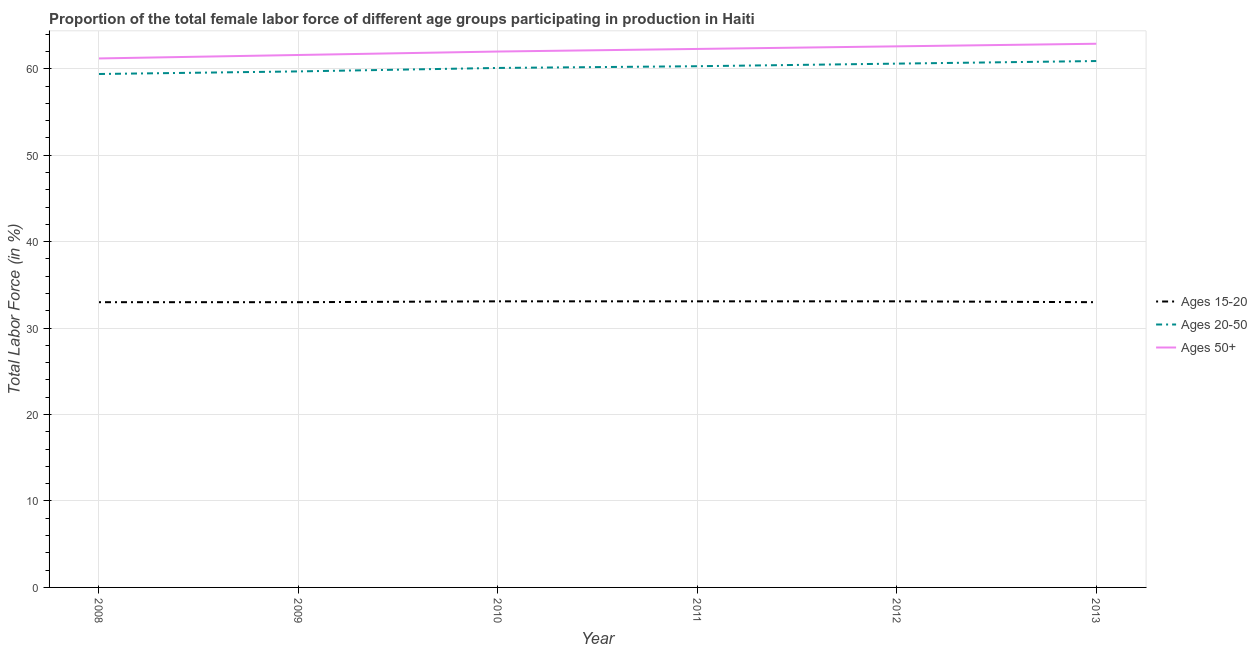How many different coloured lines are there?
Your answer should be very brief. 3. What is the percentage of female labor force above age 50 in 2011?
Offer a very short reply. 62.3. Across all years, what is the maximum percentage of female labor force above age 50?
Your answer should be very brief. 62.9. Across all years, what is the minimum percentage of female labor force within the age group 20-50?
Offer a terse response. 59.4. What is the total percentage of female labor force within the age group 15-20 in the graph?
Your answer should be very brief. 198.3. What is the difference between the percentage of female labor force within the age group 20-50 in 2009 and that in 2011?
Your response must be concise. -0.6. What is the difference between the percentage of female labor force within the age group 20-50 in 2013 and the percentage of female labor force above age 50 in 2008?
Ensure brevity in your answer.  -0.3. What is the average percentage of female labor force within the age group 20-50 per year?
Provide a short and direct response. 60.17. In the year 2009, what is the difference between the percentage of female labor force within the age group 15-20 and percentage of female labor force within the age group 20-50?
Your response must be concise. -26.7. In how many years, is the percentage of female labor force above age 50 greater than 54 %?
Provide a short and direct response. 6. What is the ratio of the percentage of female labor force within the age group 20-50 in 2009 to that in 2012?
Your answer should be compact. 0.99. Is the percentage of female labor force above age 50 in 2011 less than that in 2013?
Provide a succinct answer. Yes. What is the difference between the highest and the second highest percentage of female labor force within the age group 20-50?
Keep it short and to the point. 0.3. What is the difference between the highest and the lowest percentage of female labor force above age 50?
Give a very brief answer. 1.7. Does the percentage of female labor force within the age group 15-20 monotonically increase over the years?
Make the answer very short. No. Is the percentage of female labor force above age 50 strictly greater than the percentage of female labor force within the age group 20-50 over the years?
Your answer should be very brief. Yes. How many years are there in the graph?
Offer a very short reply. 6. How many legend labels are there?
Ensure brevity in your answer.  3. What is the title of the graph?
Offer a very short reply. Proportion of the total female labor force of different age groups participating in production in Haiti. Does "Unpaid family workers" appear as one of the legend labels in the graph?
Your answer should be compact. No. What is the label or title of the Y-axis?
Your answer should be compact. Total Labor Force (in %). What is the Total Labor Force (in %) of Ages 15-20 in 2008?
Your response must be concise. 33. What is the Total Labor Force (in %) of Ages 20-50 in 2008?
Give a very brief answer. 59.4. What is the Total Labor Force (in %) of Ages 50+ in 2008?
Make the answer very short. 61.2. What is the Total Labor Force (in %) in Ages 15-20 in 2009?
Your answer should be compact. 33. What is the Total Labor Force (in %) in Ages 20-50 in 2009?
Ensure brevity in your answer.  59.7. What is the Total Labor Force (in %) in Ages 50+ in 2009?
Your answer should be very brief. 61.6. What is the Total Labor Force (in %) of Ages 15-20 in 2010?
Offer a terse response. 33.1. What is the Total Labor Force (in %) in Ages 20-50 in 2010?
Provide a succinct answer. 60.1. What is the Total Labor Force (in %) in Ages 15-20 in 2011?
Ensure brevity in your answer.  33.1. What is the Total Labor Force (in %) in Ages 20-50 in 2011?
Offer a terse response. 60.3. What is the Total Labor Force (in %) in Ages 50+ in 2011?
Your answer should be very brief. 62.3. What is the Total Labor Force (in %) of Ages 15-20 in 2012?
Give a very brief answer. 33.1. What is the Total Labor Force (in %) of Ages 20-50 in 2012?
Offer a very short reply. 60.6. What is the Total Labor Force (in %) in Ages 50+ in 2012?
Make the answer very short. 62.6. What is the Total Labor Force (in %) in Ages 20-50 in 2013?
Keep it short and to the point. 60.9. What is the Total Labor Force (in %) in Ages 50+ in 2013?
Offer a terse response. 62.9. Across all years, what is the maximum Total Labor Force (in %) of Ages 15-20?
Your response must be concise. 33.1. Across all years, what is the maximum Total Labor Force (in %) of Ages 20-50?
Keep it short and to the point. 60.9. Across all years, what is the maximum Total Labor Force (in %) in Ages 50+?
Offer a terse response. 62.9. Across all years, what is the minimum Total Labor Force (in %) of Ages 15-20?
Ensure brevity in your answer.  33. Across all years, what is the minimum Total Labor Force (in %) in Ages 20-50?
Offer a very short reply. 59.4. Across all years, what is the minimum Total Labor Force (in %) in Ages 50+?
Give a very brief answer. 61.2. What is the total Total Labor Force (in %) of Ages 15-20 in the graph?
Provide a succinct answer. 198.3. What is the total Total Labor Force (in %) of Ages 20-50 in the graph?
Provide a short and direct response. 361. What is the total Total Labor Force (in %) in Ages 50+ in the graph?
Offer a very short reply. 372.6. What is the difference between the Total Labor Force (in %) in Ages 15-20 in 2008 and that in 2009?
Your answer should be compact. 0. What is the difference between the Total Labor Force (in %) of Ages 20-50 in 2008 and that in 2010?
Keep it short and to the point. -0.7. What is the difference between the Total Labor Force (in %) of Ages 15-20 in 2008 and that in 2011?
Keep it short and to the point. -0.1. What is the difference between the Total Labor Force (in %) in Ages 20-50 in 2008 and that in 2011?
Offer a terse response. -0.9. What is the difference between the Total Labor Force (in %) in Ages 15-20 in 2008 and that in 2012?
Provide a succinct answer. -0.1. What is the difference between the Total Labor Force (in %) of Ages 15-20 in 2008 and that in 2013?
Offer a terse response. 0. What is the difference between the Total Labor Force (in %) of Ages 20-50 in 2008 and that in 2013?
Keep it short and to the point. -1.5. What is the difference between the Total Labor Force (in %) of Ages 50+ in 2009 and that in 2010?
Give a very brief answer. -0.4. What is the difference between the Total Labor Force (in %) of Ages 15-20 in 2009 and that in 2011?
Give a very brief answer. -0.1. What is the difference between the Total Labor Force (in %) in Ages 50+ in 2009 and that in 2011?
Keep it short and to the point. -0.7. What is the difference between the Total Labor Force (in %) in Ages 20-50 in 2009 and that in 2012?
Give a very brief answer. -0.9. What is the difference between the Total Labor Force (in %) of Ages 20-50 in 2009 and that in 2013?
Provide a succinct answer. -1.2. What is the difference between the Total Labor Force (in %) of Ages 20-50 in 2010 and that in 2011?
Your response must be concise. -0.2. What is the difference between the Total Labor Force (in %) in Ages 50+ in 2010 and that in 2011?
Your answer should be compact. -0.3. What is the difference between the Total Labor Force (in %) of Ages 15-20 in 2010 and that in 2012?
Your answer should be very brief. 0. What is the difference between the Total Labor Force (in %) in Ages 15-20 in 2010 and that in 2013?
Provide a short and direct response. 0.1. What is the difference between the Total Labor Force (in %) in Ages 20-50 in 2010 and that in 2013?
Your answer should be very brief. -0.8. What is the difference between the Total Labor Force (in %) of Ages 50+ in 2011 and that in 2012?
Give a very brief answer. -0.3. What is the difference between the Total Labor Force (in %) of Ages 15-20 in 2011 and that in 2013?
Provide a short and direct response. 0.1. What is the difference between the Total Labor Force (in %) of Ages 15-20 in 2012 and that in 2013?
Give a very brief answer. 0.1. What is the difference between the Total Labor Force (in %) in Ages 20-50 in 2012 and that in 2013?
Provide a short and direct response. -0.3. What is the difference between the Total Labor Force (in %) in Ages 15-20 in 2008 and the Total Labor Force (in %) in Ages 20-50 in 2009?
Provide a short and direct response. -26.7. What is the difference between the Total Labor Force (in %) of Ages 15-20 in 2008 and the Total Labor Force (in %) of Ages 50+ in 2009?
Offer a terse response. -28.6. What is the difference between the Total Labor Force (in %) of Ages 20-50 in 2008 and the Total Labor Force (in %) of Ages 50+ in 2009?
Ensure brevity in your answer.  -2.2. What is the difference between the Total Labor Force (in %) in Ages 15-20 in 2008 and the Total Labor Force (in %) in Ages 20-50 in 2010?
Keep it short and to the point. -27.1. What is the difference between the Total Labor Force (in %) of Ages 20-50 in 2008 and the Total Labor Force (in %) of Ages 50+ in 2010?
Give a very brief answer. -2.6. What is the difference between the Total Labor Force (in %) in Ages 15-20 in 2008 and the Total Labor Force (in %) in Ages 20-50 in 2011?
Provide a succinct answer. -27.3. What is the difference between the Total Labor Force (in %) of Ages 15-20 in 2008 and the Total Labor Force (in %) of Ages 50+ in 2011?
Provide a short and direct response. -29.3. What is the difference between the Total Labor Force (in %) of Ages 20-50 in 2008 and the Total Labor Force (in %) of Ages 50+ in 2011?
Give a very brief answer. -2.9. What is the difference between the Total Labor Force (in %) in Ages 15-20 in 2008 and the Total Labor Force (in %) in Ages 20-50 in 2012?
Your response must be concise. -27.6. What is the difference between the Total Labor Force (in %) in Ages 15-20 in 2008 and the Total Labor Force (in %) in Ages 50+ in 2012?
Your answer should be compact. -29.6. What is the difference between the Total Labor Force (in %) in Ages 20-50 in 2008 and the Total Labor Force (in %) in Ages 50+ in 2012?
Keep it short and to the point. -3.2. What is the difference between the Total Labor Force (in %) in Ages 15-20 in 2008 and the Total Labor Force (in %) in Ages 20-50 in 2013?
Keep it short and to the point. -27.9. What is the difference between the Total Labor Force (in %) in Ages 15-20 in 2008 and the Total Labor Force (in %) in Ages 50+ in 2013?
Your answer should be very brief. -29.9. What is the difference between the Total Labor Force (in %) in Ages 20-50 in 2008 and the Total Labor Force (in %) in Ages 50+ in 2013?
Offer a terse response. -3.5. What is the difference between the Total Labor Force (in %) of Ages 15-20 in 2009 and the Total Labor Force (in %) of Ages 20-50 in 2010?
Give a very brief answer. -27.1. What is the difference between the Total Labor Force (in %) in Ages 20-50 in 2009 and the Total Labor Force (in %) in Ages 50+ in 2010?
Your answer should be compact. -2.3. What is the difference between the Total Labor Force (in %) in Ages 15-20 in 2009 and the Total Labor Force (in %) in Ages 20-50 in 2011?
Your response must be concise. -27.3. What is the difference between the Total Labor Force (in %) of Ages 15-20 in 2009 and the Total Labor Force (in %) of Ages 50+ in 2011?
Your answer should be compact. -29.3. What is the difference between the Total Labor Force (in %) of Ages 20-50 in 2009 and the Total Labor Force (in %) of Ages 50+ in 2011?
Offer a very short reply. -2.6. What is the difference between the Total Labor Force (in %) of Ages 15-20 in 2009 and the Total Labor Force (in %) of Ages 20-50 in 2012?
Provide a succinct answer. -27.6. What is the difference between the Total Labor Force (in %) in Ages 15-20 in 2009 and the Total Labor Force (in %) in Ages 50+ in 2012?
Make the answer very short. -29.6. What is the difference between the Total Labor Force (in %) of Ages 15-20 in 2009 and the Total Labor Force (in %) of Ages 20-50 in 2013?
Ensure brevity in your answer.  -27.9. What is the difference between the Total Labor Force (in %) of Ages 15-20 in 2009 and the Total Labor Force (in %) of Ages 50+ in 2013?
Give a very brief answer. -29.9. What is the difference between the Total Labor Force (in %) of Ages 15-20 in 2010 and the Total Labor Force (in %) of Ages 20-50 in 2011?
Provide a short and direct response. -27.2. What is the difference between the Total Labor Force (in %) of Ages 15-20 in 2010 and the Total Labor Force (in %) of Ages 50+ in 2011?
Your response must be concise. -29.2. What is the difference between the Total Labor Force (in %) of Ages 20-50 in 2010 and the Total Labor Force (in %) of Ages 50+ in 2011?
Offer a very short reply. -2.2. What is the difference between the Total Labor Force (in %) of Ages 15-20 in 2010 and the Total Labor Force (in %) of Ages 20-50 in 2012?
Offer a terse response. -27.5. What is the difference between the Total Labor Force (in %) of Ages 15-20 in 2010 and the Total Labor Force (in %) of Ages 50+ in 2012?
Give a very brief answer. -29.5. What is the difference between the Total Labor Force (in %) of Ages 15-20 in 2010 and the Total Labor Force (in %) of Ages 20-50 in 2013?
Your response must be concise. -27.8. What is the difference between the Total Labor Force (in %) in Ages 15-20 in 2010 and the Total Labor Force (in %) in Ages 50+ in 2013?
Keep it short and to the point. -29.8. What is the difference between the Total Labor Force (in %) of Ages 20-50 in 2010 and the Total Labor Force (in %) of Ages 50+ in 2013?
Your answer should be compact. -2.8. What is the difference between the Total Labor Force (in %) in Ages 15-20 in 2011 and the Total Labor Force (in %) in Ages 20-50 in 2012?
Provide a short and direct response. -27.5. What is the difference between the Total Labor Force (in %) of Ages 15-20 in 2011 and the Total Labor Force (in %) of Ages 50+ in 2012?
Your answer should be very brief. -29.5. What is the difference between the Total Labor Force (in %) in Ages 20-50 in 2011 and the Total Labor Force (in %) in Ages 50+ in 2012?
Ensure brevity in your answer.  -2.3. What is the difference between the Total Labor Force (in %) of Ages 15-20 in 2011 and the Total Labor Force (in %) of Ages 20-50 in 2013?
Offer a terse response. -27.8. What is the difference between the Total Labor Force (in %) in Ages 15-20 in 2011 and the Total Labor Force (in %) in Ages 50+ in 2013?
Your answer should be compact. -29.8. What is the difference between the Total Labor Force (in %) of Ages 15-20 in 2012 and the Total Labor Force (in %) of Ages 20-50 in 2013?
Offer a very short reply. -27.8. What is the difference between the Total Labor Force (in %) of Ages 15-20 in 2012 and the Total Labor Force (in %) of Ages 50+ in 2013?
Make the answer very short. -29.8. What is the difference between the Total Labor Force (in %) of Ages 20-50 in 2012 and the Total Labor Force (in %) of Ages 50+ in 2013?
Your response must be concise. -2.3. What is the average Total Labor Force (in %) in Ages 15-20 per year?
Keep it short and to the point. 33.05. What is the average Total Labor Force (in %) of Ages 20-50 per year?
Your answer should be compact. 60.17. What is the average Total Labor Force (in %) of Ages 50+ per year?
Provide a short and direct response. 62.1. In the year 2008, what is the difference between the Total Labor Force (in %) of Ages 15-20 and Total Labor Force (in %) of Ages 20-50?
Keep it short and to the point. -26.4. In the year 2008, what is the difference between the Total Labor Force (in %) of Ages 15-20 and Total Labor Force (in %) of Ages 50+?
Provide a short and direct response. -28.2. In the year 2008, what is the difference between the Total Labor Force (in %) in Ages 20-50 and Total Labor Force (in %) in Ages 50+?
Make the answer very short. -1.8. In the year 2009, what is the difference between the Total Labor Force (in %) in Ages 15-20 and Total Labor Force (in %) in Ages 20-50?
Ensure brevity in your answer.  -26.7. In the year 2009, what is the difference between the Total Labor Force (in %) in Ages 15-20 and Total Labor Force (in %) in Ages 50+?
Keep it short and to the point. -28.6. In the year 2009, what is the difference between the Total Labor Force (in %) in Ages 20-50 and Total Labor Force (in %) in Ages 50+?
Your answer should be compact. -1.9. In the year 2010, what is the difference between the Total Labor Force (in %) of Ages 15-20 and Total Labor Force (in %) of Ages 20-50?
Provide a succinct answer. -27. In the year 2010, what is the difference between the Total Labor Force (in %) in Ages 15-20 and Total Labor Force (in %) in Ages 50+?
Offer a terse response. -28.9. In the year 2010, what is the difference between the Total Labor Force (in %) of Ages 20-50 and Total Labor Force (in %) of Ages 50+?
Your answer should be compact. -1.9. In the year 2011, what is the difference between the Total Labor Force (in %) of Ages 15-20 and Total Labor Force (in %) of Ages 20-50?
Offer a very short reply. -27.2. In the year 2011, what is the difference between the Total Labor Force (in %) in Ages 15-20 and Total Labor Force (in %) in Ages 50+?
Your answer should be compact. -29.2. In the year 2011, what is the difference between the Total Labor Force (in %) of Ages 20-50 and Total Labor Force (in %) of Ages 50+?
Keep it short and to the point. -2. In the year 2012, what is the difference between the Total Labor Force (in %) of Ages 15-20 and Total Labor Force (in %) of Ages 20-50?
Provide a short and direct response. -27.5. In the year 2012, what is the difference between the Total Labor Force (in %) of Ages 15-20 and Total Labor Force (in %) of Ages 50+?
Ensure brevity in your answer.  -29.5. In the year 2013, what is the difference between the Total Labor Force (in %) of Ages 15-20 and Total Labor Force (in %) of Ages 20-50?
Your response must be concise. -27.9. In the year 2013, what is the difference between the Total Labor Force (in %) of Ages 15-20 and Total Labor Force (in %) of Ages 50+?
Offer a very short reply. -29.9. What is the ratio of the Total Labor Force (in %) of Ages 15-20 in 2008 to that in 2009?
Give a very brief answer. 1. What is the ratio of the Total Labor Force (in %) of Ages 20-50 in 2008 to that in 2009?
Offer a very short reply. 0.99. What is the ratio of the Total Labor Force (in %) of Ages 50+ in 2008 to that in 2009?
Keep it short and to the point. 0.99. What is the ratio of the Total Labor Force (in %) of Ages 15-20 in 2008 to that in 2010?
Provide a succinct answer. 1. What is the ratio of the Total Labor Force (in %) of Ages 20-50 in 2008 to that in 2010?
Offer a very short reply. 0.99. What is the ratio of the Total Labor Force (in %) of Ages 50+ in 2008 to that in 2010?
Give a very brief answer. 0.99. What is the ratio of the Total Labor Force (in %) in Ages 15-20 in 2008 to that in 2011?
Offer a terse response. 1. What is the ratio of the Total Labor Force (in %) in Ages 20-50 in 2008 to that in 2011?
Offer a very short reply. 0.99. What is the ratio of the Total Labor Force (in %) in Ages 50+ in 2008 to that in 2011?
Make the answer very short. 0.98. What is the ratio of the Total Labor Force (in %) of Ages 15-20 in 2008 to that in 2012?
Make the answer very short. 1. What is the ratio of the Total Labor Force (in %) in Ages 20-50 in 2008 to that in 2012?
Ensure brevity in your answer.  0.98. What is the ratio of the Total Labor Force (in %) in Ages 50+ in 2008 to that in 2012?
Your answer should be compact. 0.98. What is the ratio of the Total Labor Force (in %) of Ages 20-50 in 2008 to that in 2013?
Offer a very short reply. 0.98. What is the ratio of the Total Labor Force (in %) in Ages 20-50 in 2009 to that in 2010?
Ensure brevity in your answer.  0.99. What is the ratio of the Total Labor Force (in %) in Ages 50+ in 2009 to that in 2010?
Offer a terse response. 0.99. What is the ratio of the Total Labor Force (in %) in Ages 15-20 in 2009 to that in 2011?
Make the answer very short. 1. What is the ratio of the Total Labor Force (in %) in Ages 20-50 in 2009 to that in 2012?
Provide a short and direct response. 0.99. What is the ratio of the Total Labor Force (in %) in Ages 15-20 in 2009 to that in 2013?
Offer a very short reply. 1. What is the ratio of the Total Labor Force (in %) of Ages 20-50 in 2009 to that in 2013?
Keep it short and to the point. 0.98. What is the ratio of the Total Labor Force (in %) of Ages 50+ in 2009 to that in 2013?
Your response must be concise. 0.98. What is the ratio of the Total Labor Force (in %) in Ages 15-20 in 2010 to that in 2011?
Offer a terse response. 1. What is the ratio of the Total Labor Force (in %) of Ages 20-50 in 2010 to that in 2011?
Provide a short and direct response. 1. What is the ratio of the Total Labor Force (in %) in Ages 50+ in 2010 to that in 2011?
Your answer should be very brief. 1. What is the ratio of the Total Labor Force (in %) in Ages 15-20 in 2010 to that in 2012?
Your answer should be compact. 1. What is the ratio of the Total Labor Force (in %) in Ages 20-50 in 2010 to that in 2012?
Provide a succinct answer. 0.99. What is the ratio of the Total Labor Force (in %) of Ages 50+ in 2010 to that in 2012?
Offer a terse response. 0.99. What is the ratio of the Total Labor Force (in %) in Ages 20-50 in 2010 to that in 2013?
Provide a short and direct response. 0.99. What is the ratio of the Total Labor Force (in %) of Ages 50+ in 2010 to that in 2013?
Keep it short and to the point. 0.99. What is the ratio of the Total Labor Force (in %) in Ages 15-20 in 2011 to that in 2012?
Keep it short and to the point. 1. What is the ratio of the Total Labor Force (in %) of Ages 20-50 in 2011 to that in 2012?
Offer a terse response. 0.99. What is the ratio of the Total Labor Force (in %) of Ages 50+ in 2011 to that in 2012?
Your answer should be compact. 1. What is the ratio of the Total Labor Force (in %) of Ages 20-50 in 2011 to that in 2013?
Offer a terse response. 0.99. What is the ratio of the Total Labor Force (in %) in Ages 15-20 in 2012 to that in 2013?
Offer a very short reply. 1. What is the difference between the highest and the second highest Total Labor Force (in %) in Ages 20-50?
Provide a succinct answer. 0.3. What is the difference between the highest and the second highest Total Labor Force (in %) in Ages 50+?
Make the answer very short. 0.3. What is the difference between the highest and the lowest Total Labor Force (in %) of Ages 20-50?
Your answer should be very brief. 1.5. What is the difference between the highest and the lowest Total Labor Force (in %) in Ages 50+?
Provide a succinct answer. 1.7. 